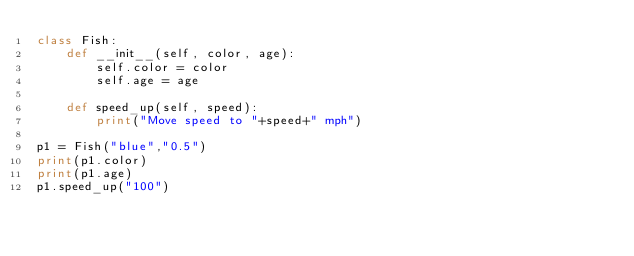<code> <loc_0><loc_0><loc_500><loc_500><_Python_>class Fish:
    def __init__(self, color, age):
        self.color = color
        self.age = age

    def speed_up(self, speed):
        print("Move speed to "+speed+" mph")

p1 = Fish("blue","0.5")
print(p1.color)
print(p1.age)
p1.speed_up("100")</code> 